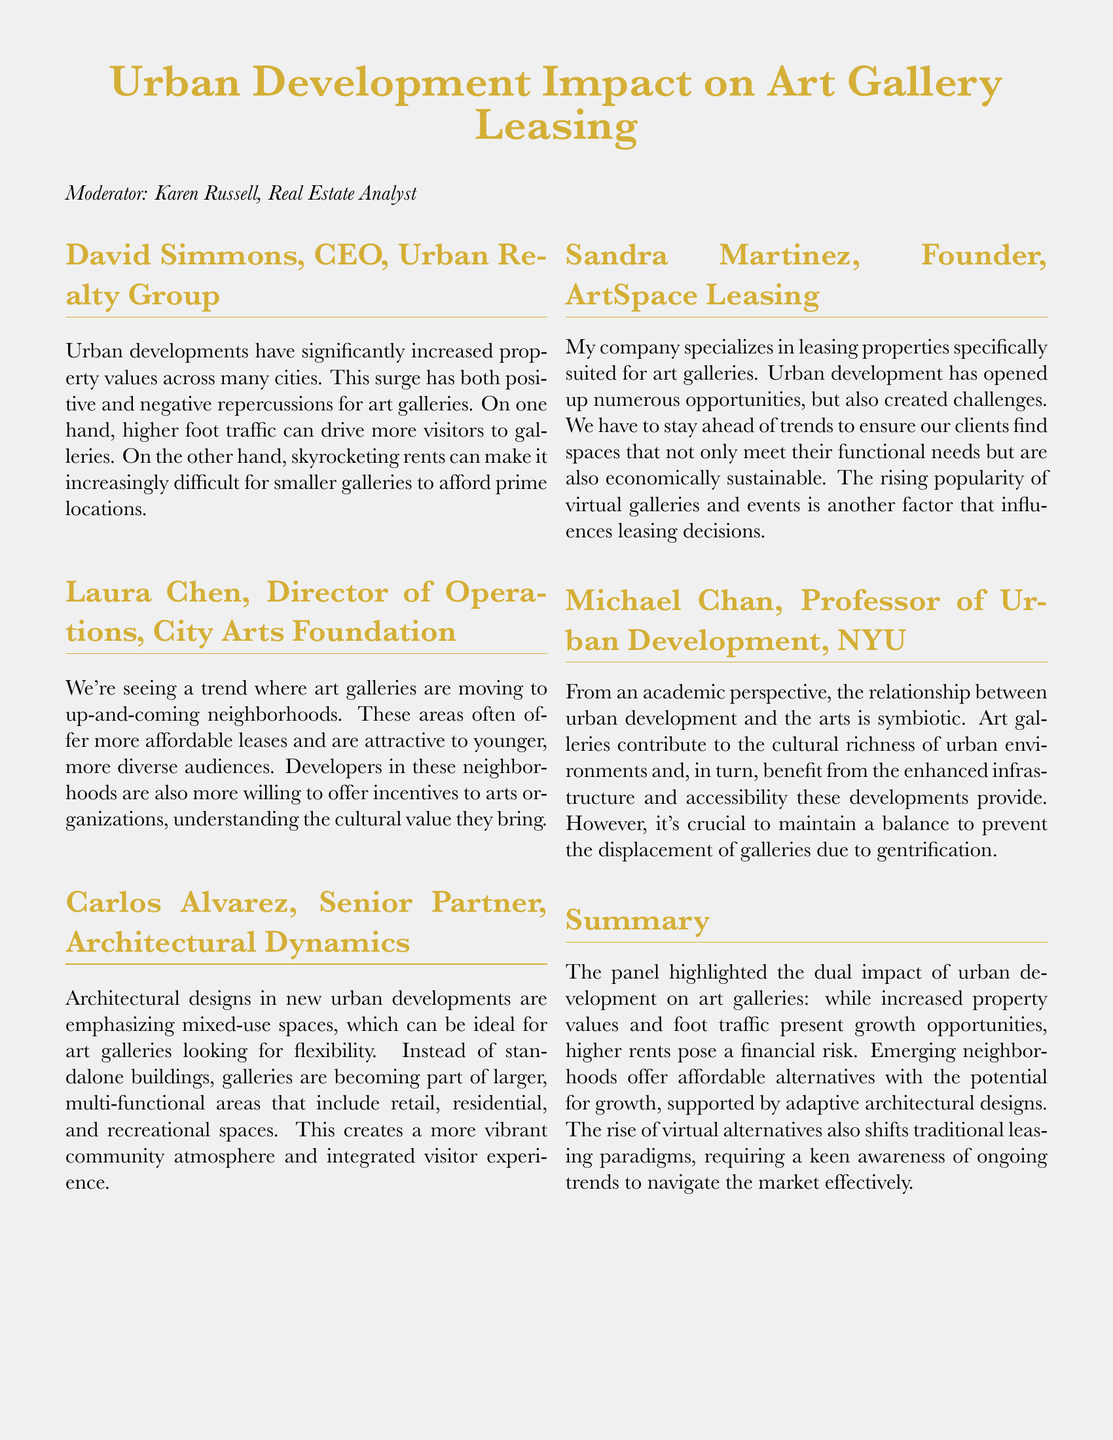What is the title of the panel discussion? The title is the main topic presented at the beginning of the document.
Answer: Urban Development Impact on Art Gallery Leasing Who is the moderator of the panel? The moderator is mentioned at the start of the document as overseeing the discussion.
Answer: Karen Russell What trend is noted about art galleries in relation to neighborhood changes? This trend indicates how galleries are responding to urban development and shifts in demographics.
Answer: Moving to up-and-coming neighborhoods Which architectural feature is emphasized for new urban developments? This feature is important for adapting spaces for art galleries within larger areas.
Answer: Mixed-use spaces Who is the founder of ArtSpace Leasing? This name identifies the individual responsible for the company that specializes in leasing to art galleries.
Answer: Sandra Martinez What dual impact does urban development have on art galleries? This phrase summarizes the key effects discussed regarding economic opportunities and challenges.
Answer: Growth opportunities and higher rents How do younger audiences affect art gallery leasing? This aspect describes the demographic trend influencing the locations where galleries are setting up.
Answer: Attracted to up-and-coming neighborhoods What rising trend is mentioned that influences leasing decisions? This trend reflects the changing dynamics in how art is being exhibited and consumed today.
Answer: Virtual galleries and events What is a key relationship highlighted between urban development and the arts? This relationship captures the mutual benefits of urban growth and artistic presence in cities.
Answer: Symbiotic relationship 